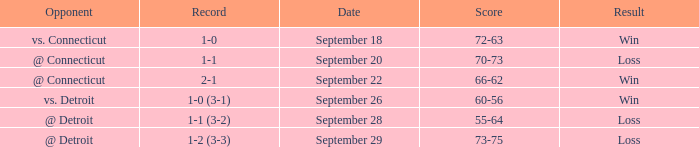WHAT IS THE SCORE WITH A RECORD OF 1-0? 72-63. 